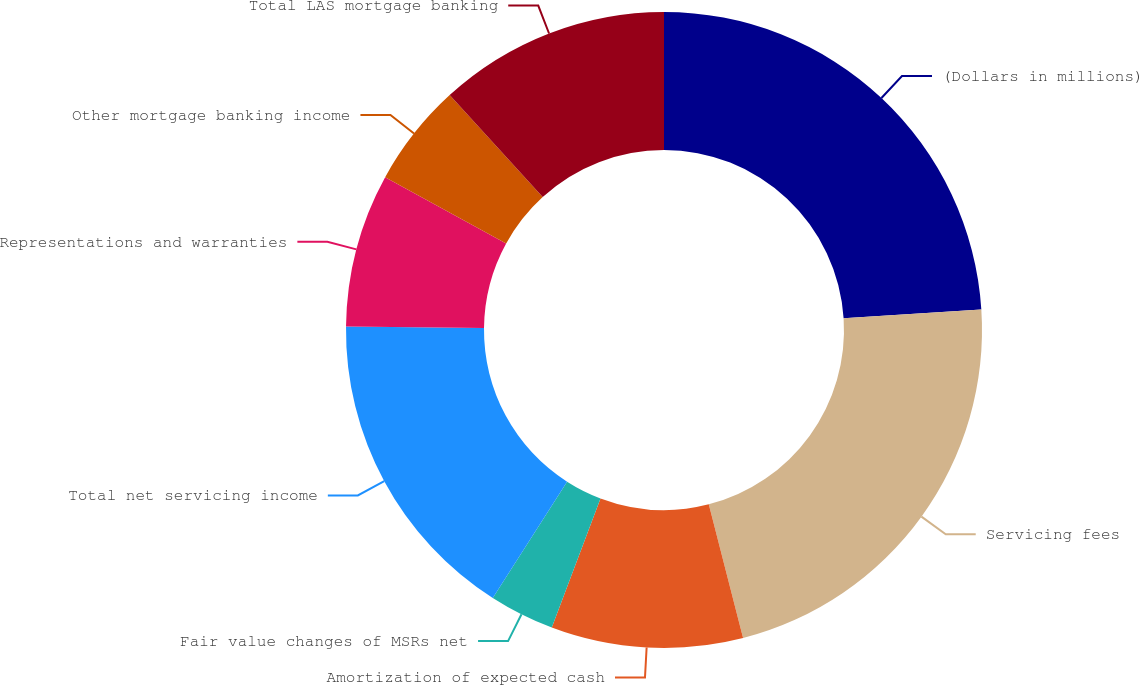Convert chart to OTSL. <chart><loc_0><loc_0><loc_500><loc_500><pie_chart><fcel>(Dollars in millions)<fcel>Servicing fees<fcel>Amortization of expected cash<fcel>Fair value changes of MSRs net<fcel>Total net servicing income<fcel>Representations and warranties<fcel>Other mortgage banking income<fcel>Total LAS mortgage banking<nl><fcel>23.97%<fcel>22.03%<fcel>9.74%<fcel>3.31%<fcel>16.13%<fcel>7.8%<fcel>5.25%<fcel>11.77%<nl></chart> 